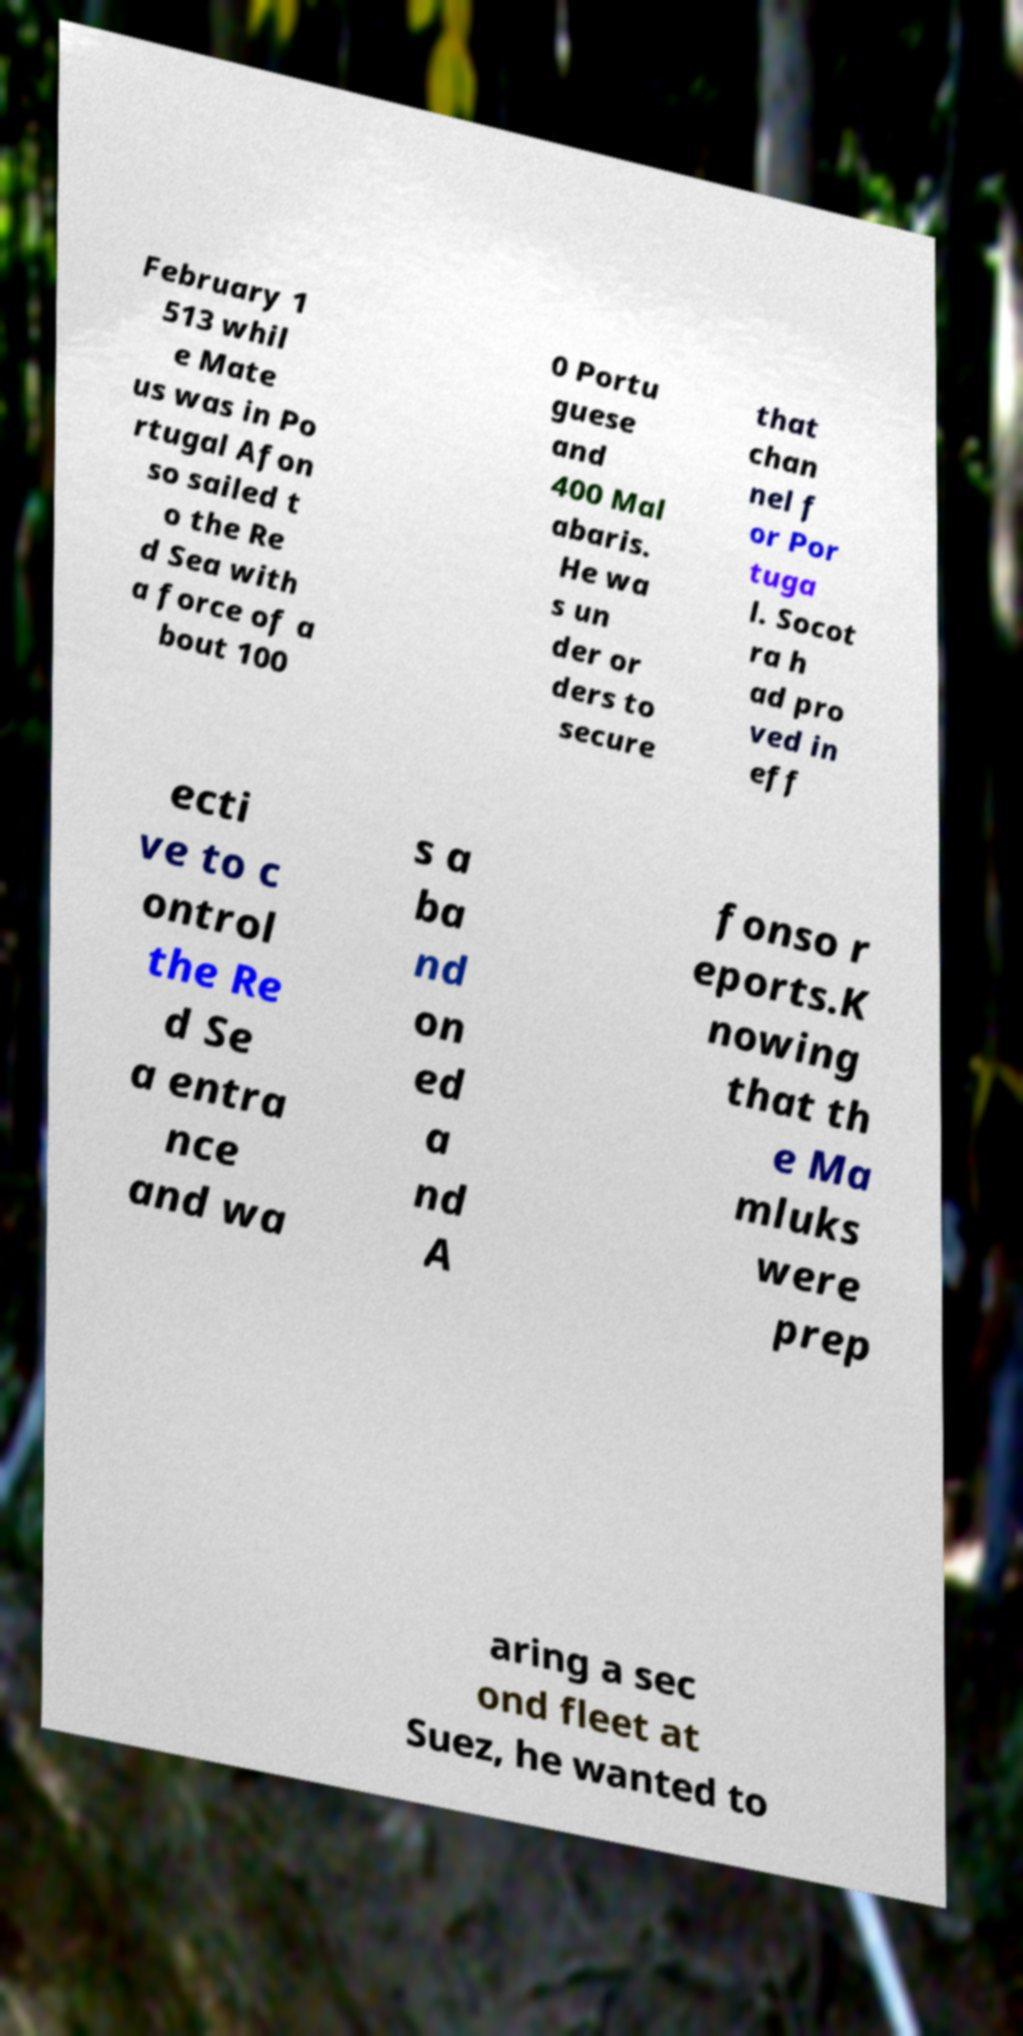Can you read and provide the text displayed in the image?This photo seems to have some interesting text. Can you extract and type it out for me? February 1 513 whil e Mate us was in Po rtugal Afon so sailed t o the Re d Sea with a force of a bout 100 0 Portu guese and 400 Mal abaris. He wa s un der or ders to secure that chan nel f or Por tuga l. Socot ra h ad pro ved in eff ecti ve to c ontrol the Re d Se a entra nce and wa s a ba nd on ed a nd A fonso r eports.K nowing that th e Ma mluks were prep aring a sec ond fleet at Suez, he wanted to 